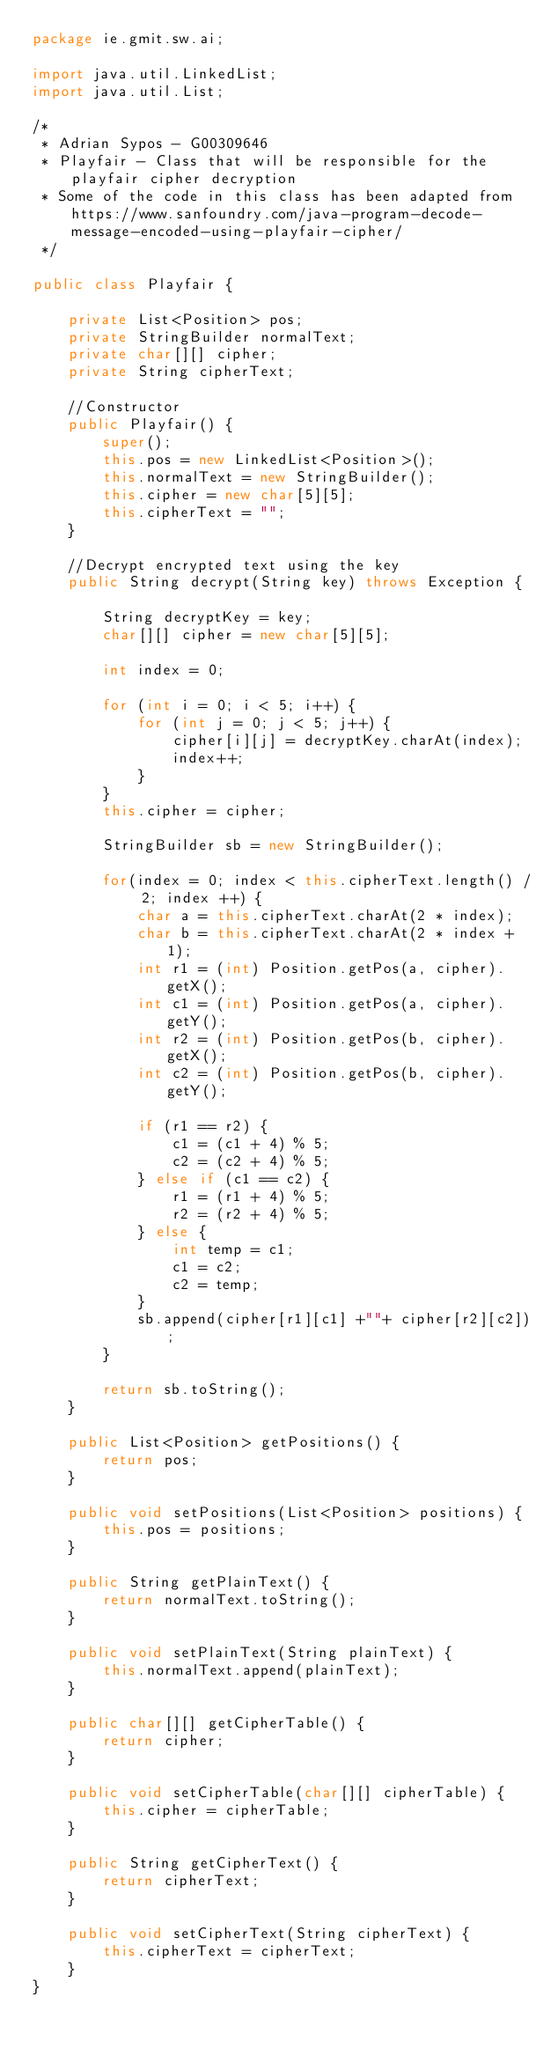<code> <loc_0><loc_0><loc_500><loc_500><_Java_>package ie.gmit.sw.ai;

import java.util.LinkedList;
import java.util.List;

/*
 * Adrian Sypos - G00309646
 * Playfair - Class that will be responsible for the playfair cipher decryption
 * Some of the code in this class has been adapted from https://www.sanfoundry.com/java-program-decode-message-encoded-using-playfair-cipher/
 */

public class Playfair {

	private List<Position> pos;
	private StringBuilder normalText;
	private char[][] cipher;
	private String cipherText;

	//Constructor
	public Playfair() {
		super();
		this.pos = new LinkedList<Position>();
		this.normalText = new StringBuilder();
		this.cipher = new char[5][5];
		this.cipherText = "";
	}
	
	//Decrypt encrypted text using the key
	public String decrypt(String key) throws Exception {
		
		String decryptKey = key;
		char[][] cipher = new char[5][5];

		int index = 0;

		for (int i = 0; i < 5; i++) {
			for (int j = 0; j < 5; j++) {
				cipher[i][j] = decryptKey.charAt(index);
				index++;
			}
		}
		this.cipher = cipher;
		
		StringBuilder sb = new StringBuilder();
		
		for(index = 0; index < this.cipherText.length() / 2; index ++) {
			char a = this.cipherText.charAt(2 * index);
			char b = this.cipherText.charAt(2 * index + 1);
			int r1 = (int) Position.getPos(a, cipher).getX();
			int c1 = (int) Position.getPos(a, cipher).getY();
			int r2 = (int) Position.getPos(b, cipher).getX();
			int c2 = (int) Position.getPos(b, cipher).getY();

			if (r1 == r2) {
				c1 = (c1 + 4) % 5; 
				c2 = (c2 + 4) % 5;
			} else if (c1 == c2) {
				r1 = (r1 + 4) % 5;
				r2 = (r2 + 4) % 5;
			} else {
		        int temp = c1;
		        c1 = c2;
		        c2 = temp;
		    }
			sb.append(cipher[r1][c1] +""+ cipher[r2][c2]);
		}
		
		return sb.toString();
	}

	public List<Position> getPositions() {
		return pos;
	}

	public void setPositions(List<Position> positions) {
		this.pos = positions;
	}

	public String getPlainText() {
		return normalText.toString();
	}

	public void setPlainText(String plainText) {
		this.normalText.append(plainText);
	}

	public char[][] getCipherTable() {
		return cipher;
	}

	public void setCipherTable(char[][] cipherTable) {
		this.cipher = cipherTable;
	}

	public String getCipherText() {
		return cipherText;
	}

	public void setCipherText(String cipherText) {
		this.cipherText = cipherText;
	}
}
</code> 